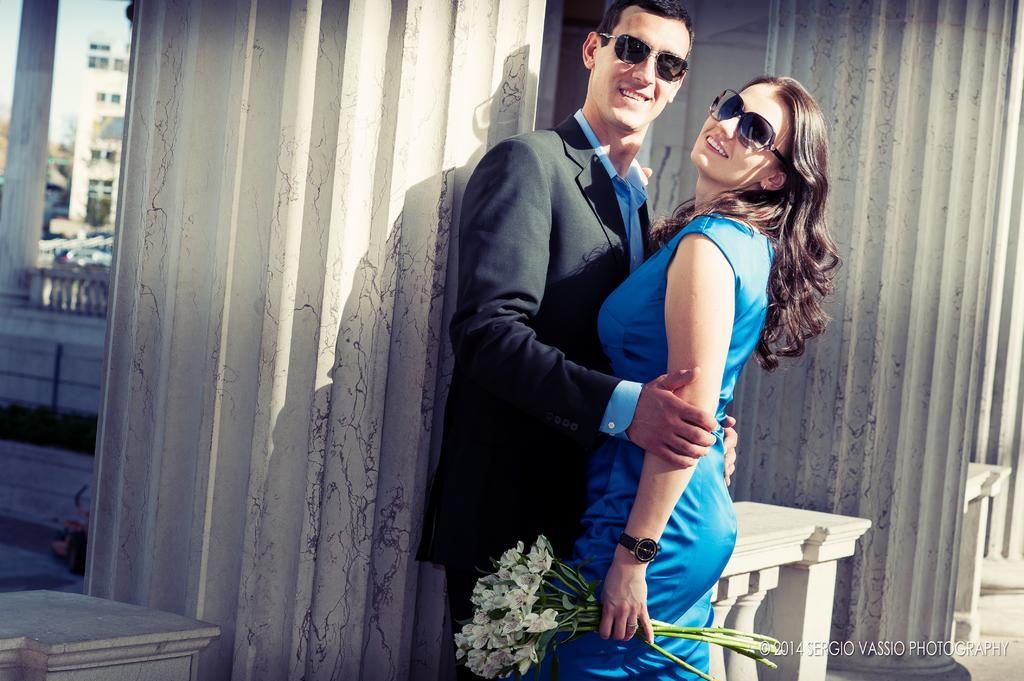In one or two sentences, can you explain what this image depicts? In the image we can see a man and a woman standing, they are wearing clothes, goggles, we can even see the woman is wearing a wristwatch and holding flowers in hand. Here we can see the building and on the bottom right we can see the watermark. 